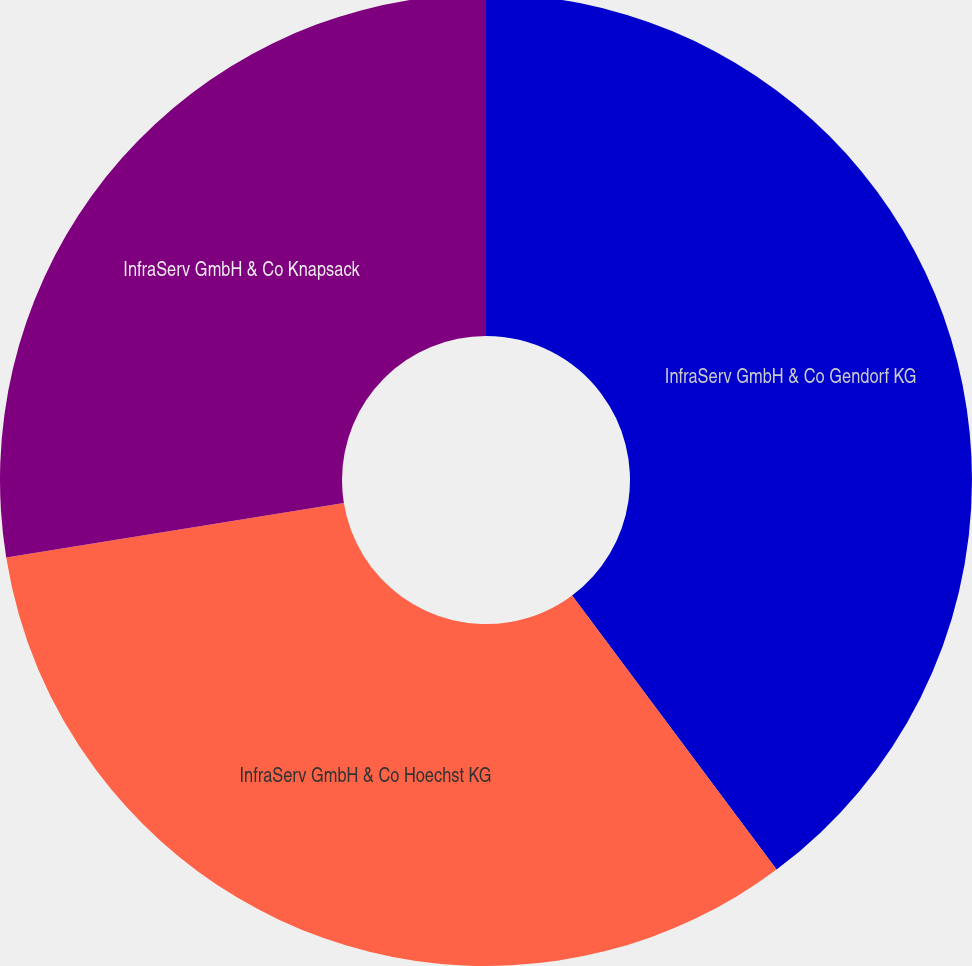Convert chart. <chart><loc_0><loc_0><loc_500><loc_500><pie_chart><fcel>InfraServ GmbH & Co Gendorf KG<fcel>InfraServ GmbH & Co Hoechst KG<fcel>InfraServ GmbH & Co Knapsack<nl><fcel>39.8%<fcel>32.65%<fcel>27.55%<nl></chart> 